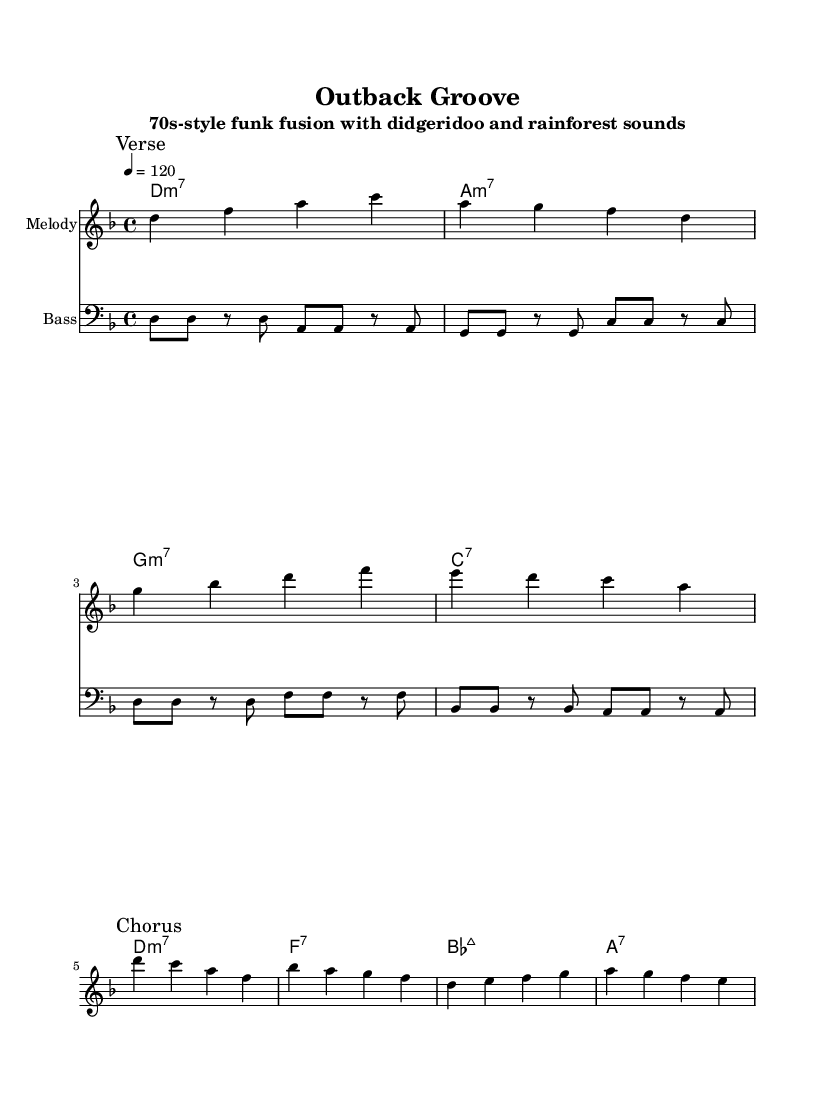What is the key signature of this music? The key signature shows one flat, indicating that the music is in D minor.
Answer: D minor What is the time signature of this music? The time signature indicated at the beginning of the score is 4/4, which means there are four beats in each measure.
Answer: 4/4 What is the tempo of the piece? The tempo marking indicates a speed of 120 beats per minute, which is written as "4 = 120".
Answer: 120 How many measures are there in the verse? The verse section, marked in the melody, consists of four measures. By counting the measures between the "Verse" and "Chorus" marks, we can see they add up to four.
Answer: 4 What is the first chord in the chorus? The first chord listed in the chorus is D minor 7, shown in the chord names below the melody.
Answer: D minor 7 How many distinct chords are used in the verse section? In the verse section, four distinct chords are used: D minor 7, A minor 7, G minor 7, and C7. Counting them gives us four unique chords.
Answer: 4 What type of music fusion is represented in this piece? The title specifies that this is a 70s-style funk fusion, combining elements of funk with didgeridoo and rainforest sounds.
Answer: Funk fusion 